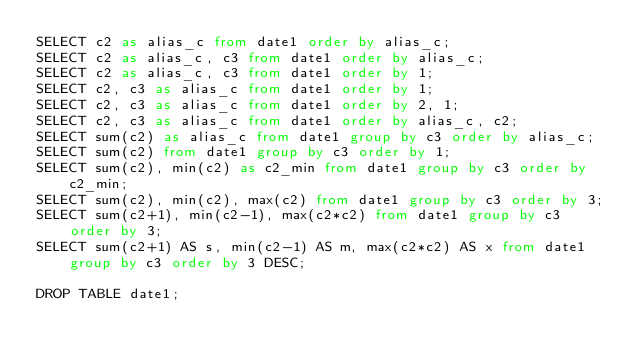<code> <loc_0><loc_0><loc_500><loc_500><_SQL_>SELECT c2 as alias_c from date1 order by alias_c;
SELECT c2 as alias_c, c3 from date1 order by alias_c;
SELECT c2 as alias_c, c3 from date1 order by 1;
SELECT c2, c3 as alias_c from date1 order by 1;
SELECT c2, c3 as alias_c from date1 order by 2, 1;
SELECT c2, c3 as alias_c from date1 order by alias_c, c2;
SELECT sum(c2) as alias_c from date1 group by c3 order by alias_c;
SELECT sum(c2) from date1 group by c3 order by 1;
SELECT sum(c2), min(c2) as c2_min from date1 group by c3 order by c2_min;
SELECT sum(c2), min(c2), max(c2) from date1 group by c3 order by 3;
SELECT sum(c2+1), min(c2-1), max(c2*c2) from date1 group by c3 order by 3;
SELECT sum(c2+1) AS s, min(c2-1) AS m, max(c2*c2) AS x from date1 group by c3 order by 3 DESC;

DROP TABLE date1;
</code> 